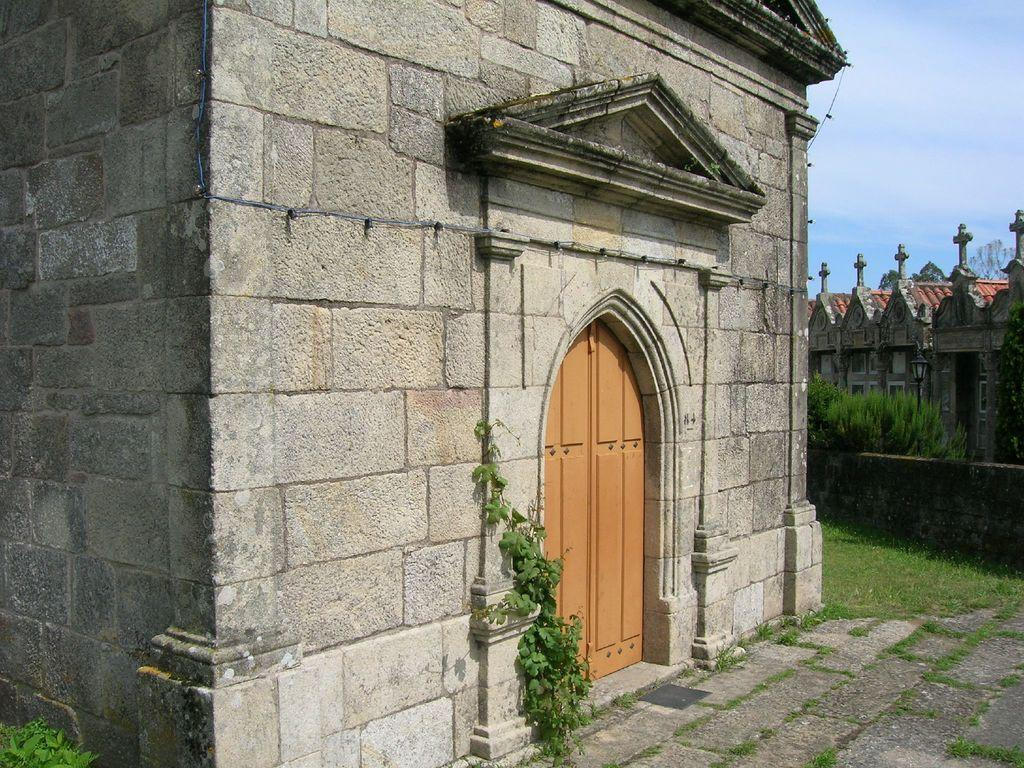What type of structure is visible in the image? There is a building in the image. What feature of the building is highlighted in the image? There is a door in the image, which appears to be a boundary. What type of vegetation can be seen in the image? There are plants and trees in the image. What type of face can be seen on the building in the image? There is no face visible on the building in the image. What type of country is depicted in the image? The image does not depict a country; it shows a building with a door and surrounding vegetation. 